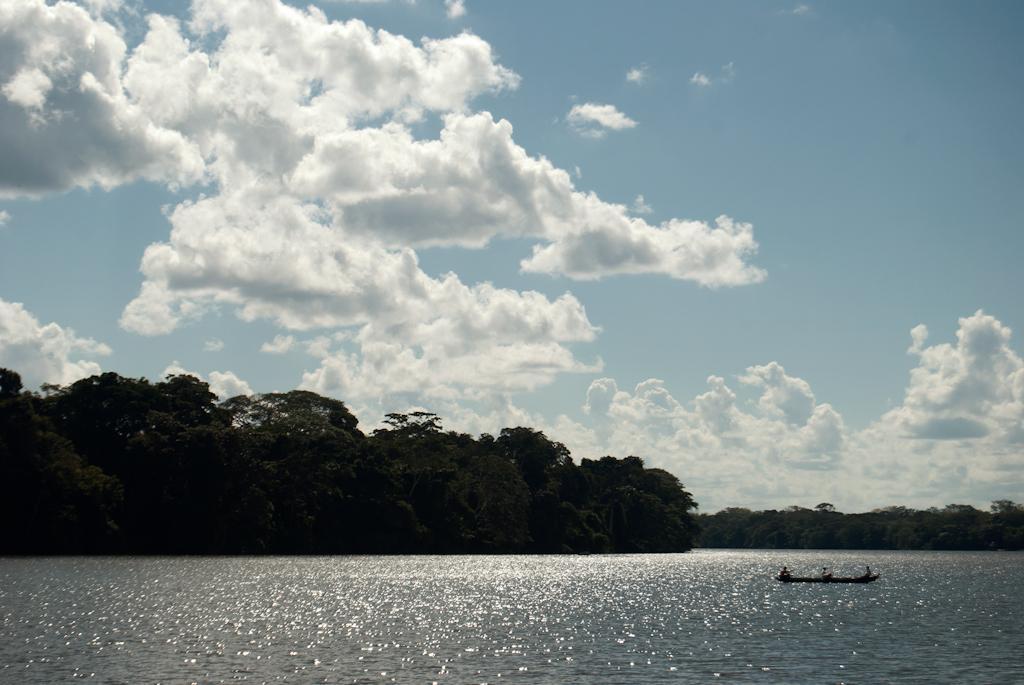Describe this image in one or two sentences. In this image we can see many trees. There is sky with the clouds. At the bottom we can see the boat on the surface of the river. 